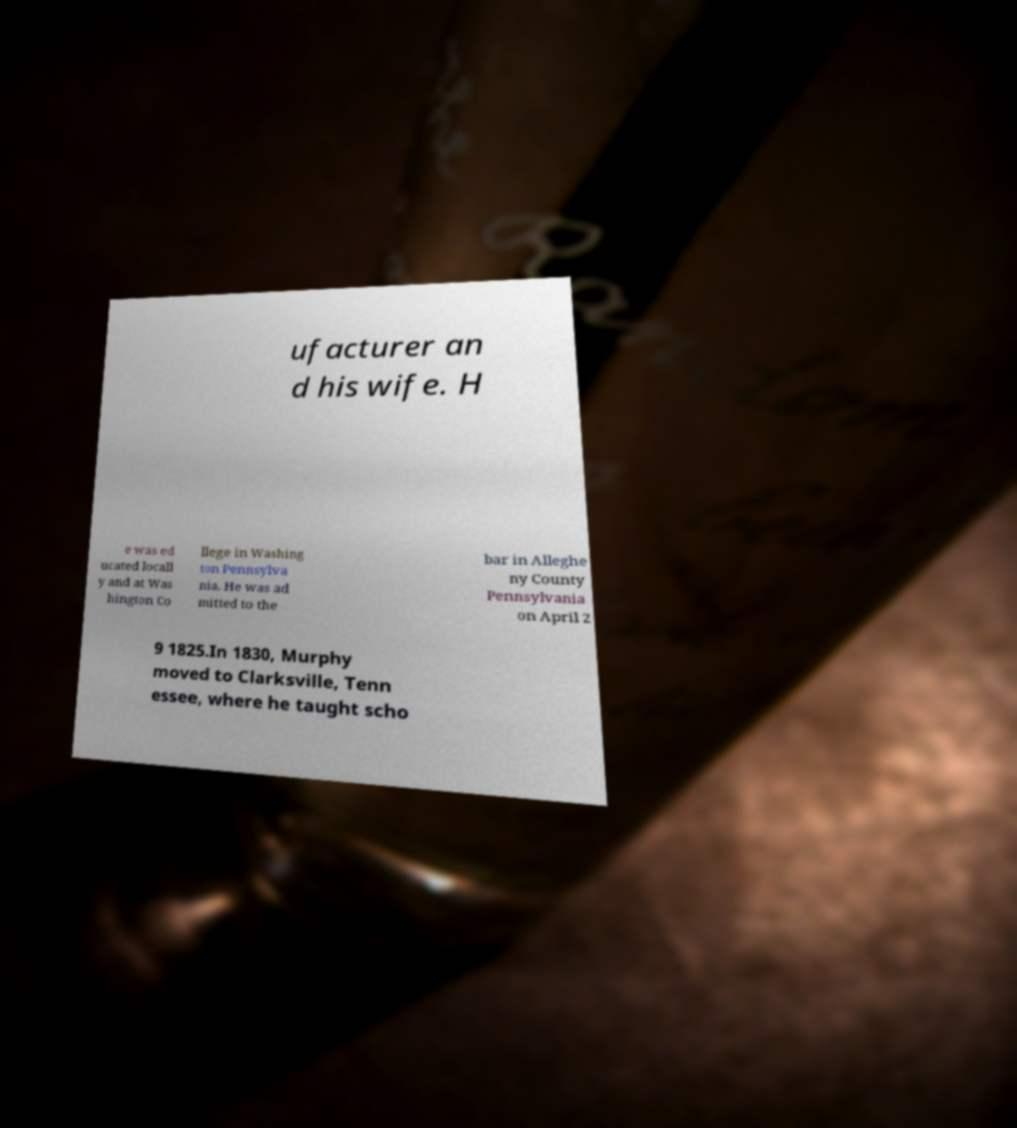For documentation purposes, I need the text within this image transcribed. Could you provide that? ufacturer an d his wife. H e was ed ucated locall y and at Was hington Co llege in Washing ton Pennsylva nia. He was ad mitted to the bar in Alleghe ny County Pennsylvania on April 2 9 1825.In 1830, Murphy moved to Clarksville, Tenn essee, where he taught scho 